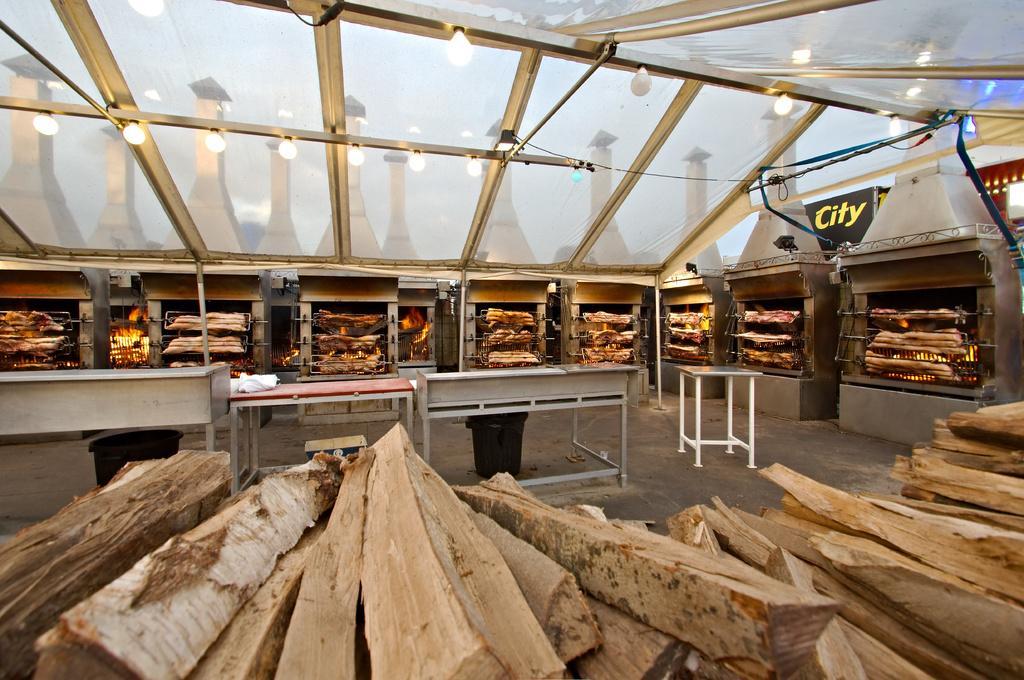Please provide a concise description of this image. This image consists of wooden pieces. In the middle, there are tables. In the background, we can see many furnaces. In which, there is fire. At the top, there is a roof along with lamps. 